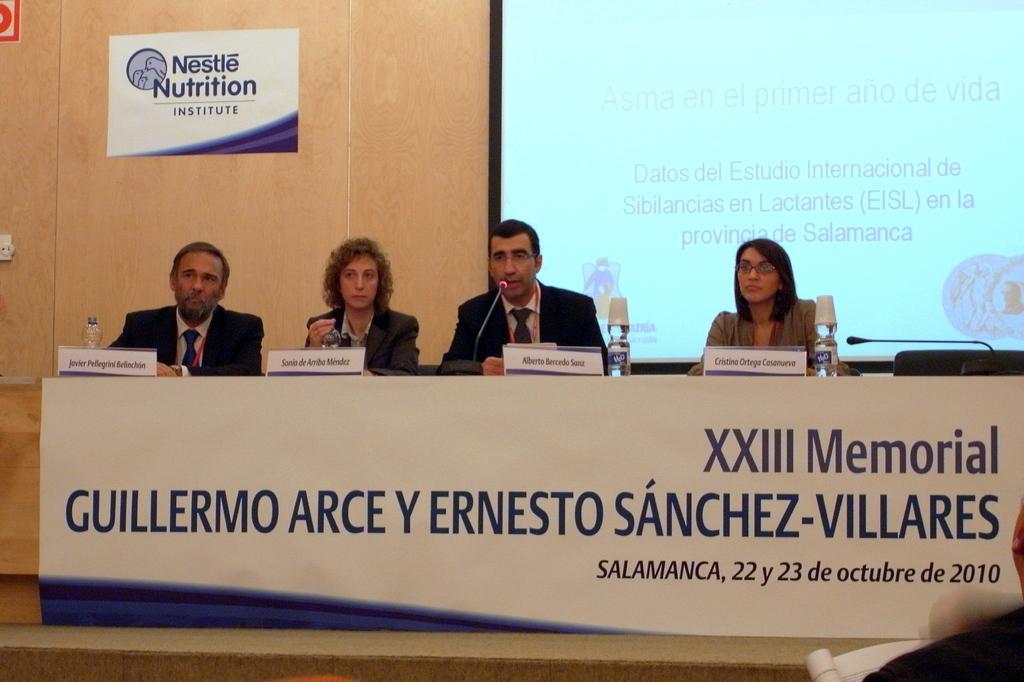Describe this image in one or two sentences. In this image there are a few people sitting in front of the table. On the table there are name plates, bottles, mics and a few other objects. On the bottom right side of the image there is a person. In the background there is a screen and few posters are attached to the wall. 